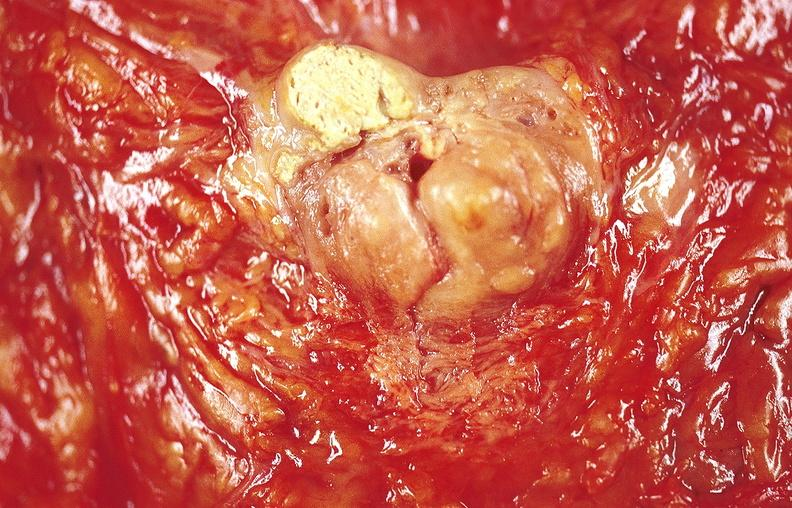where does this belong to?
Answer the question using a single word or phrase. Gastrointestinal system 